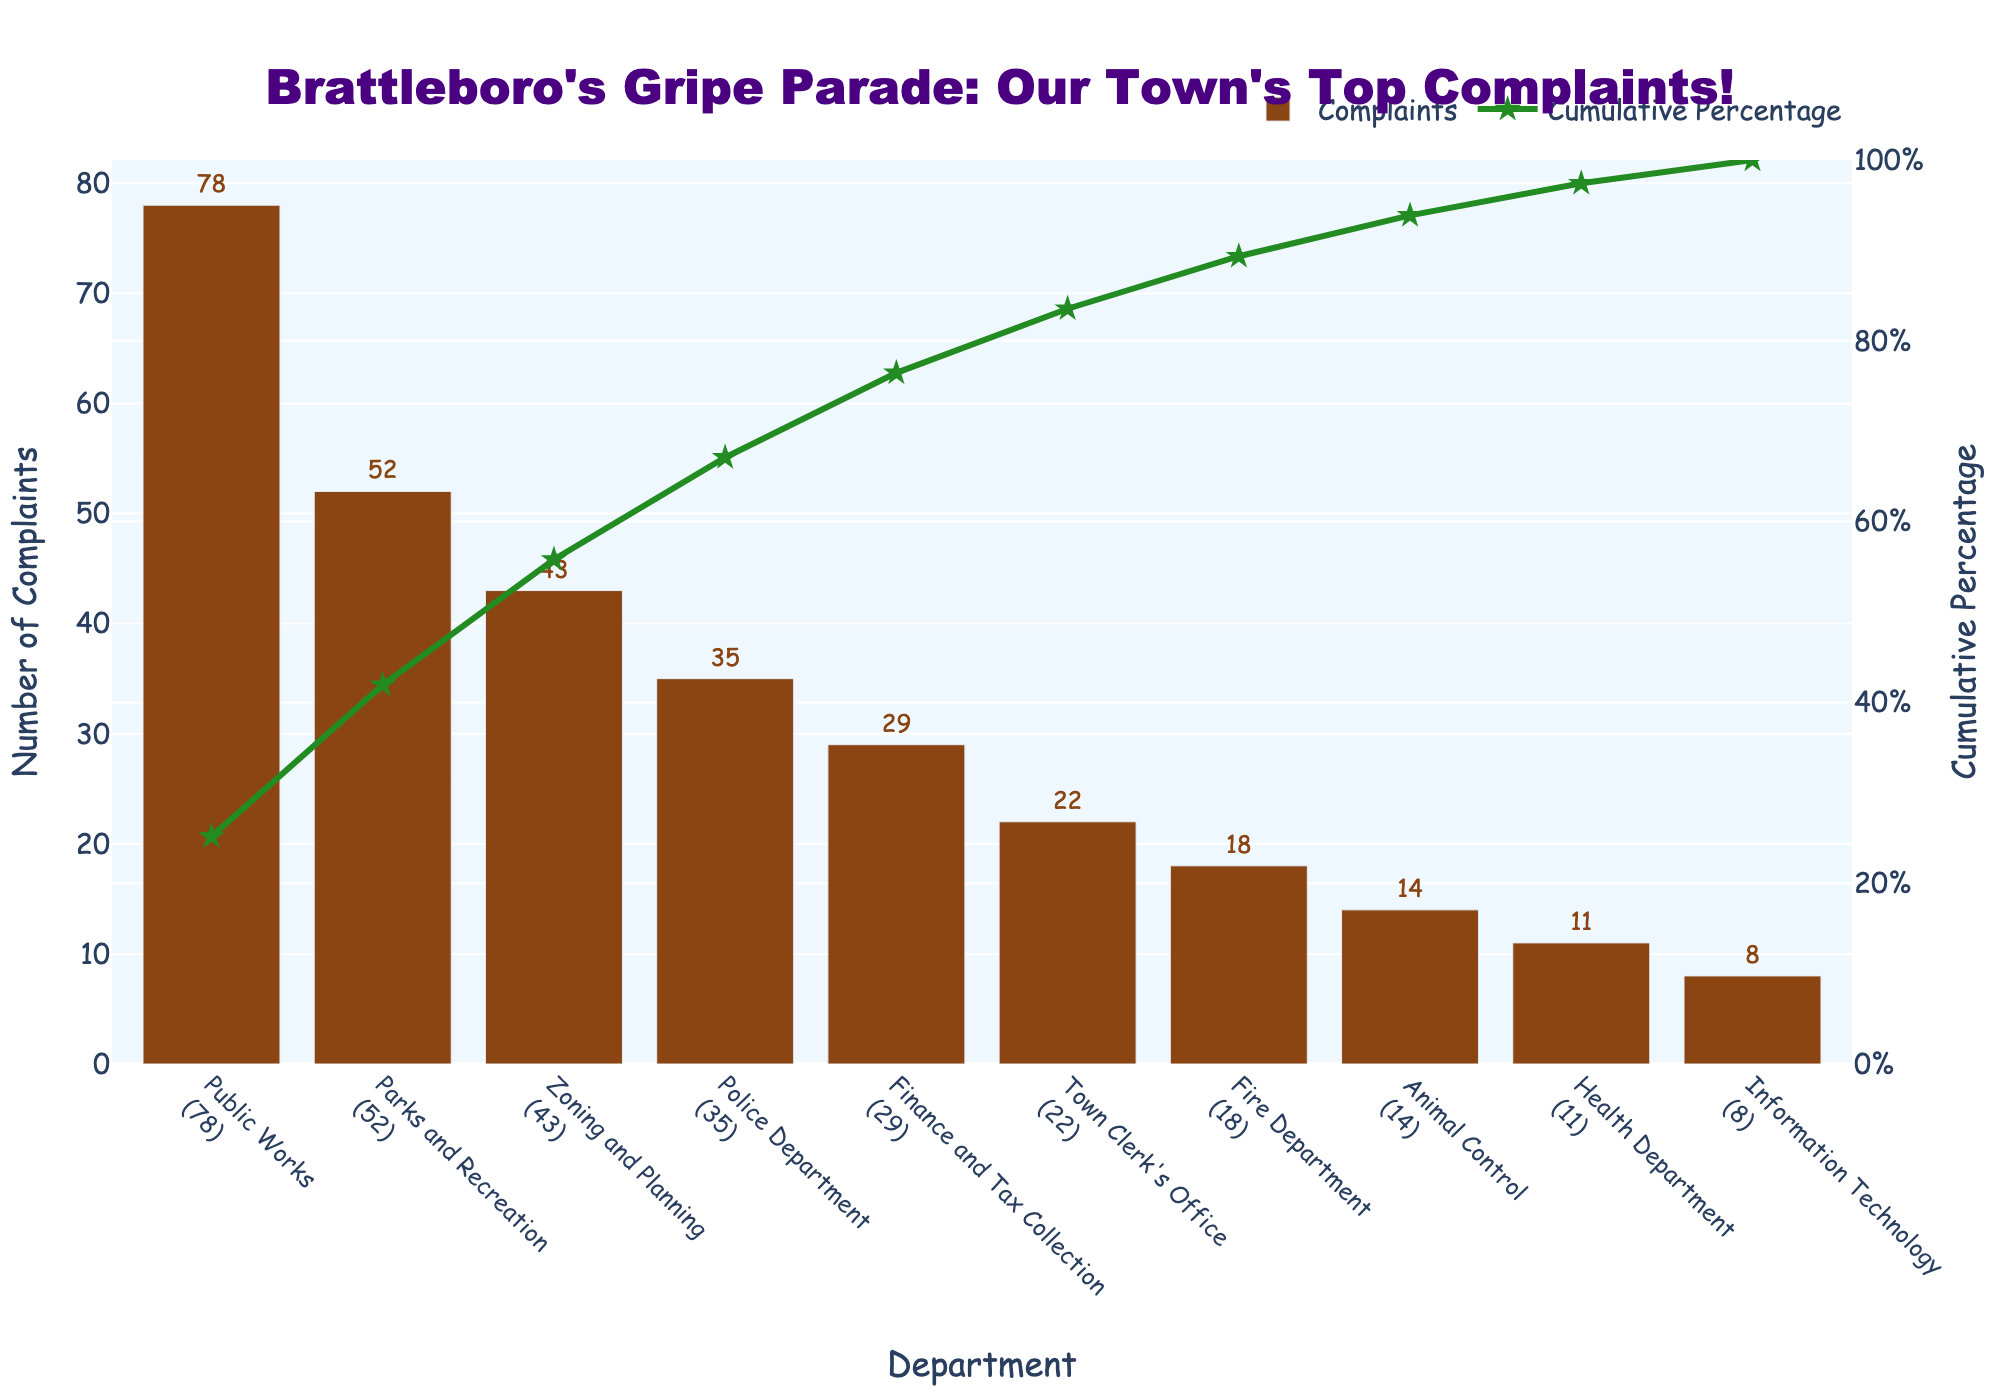What is the title of the figure? The title of the figure is located at the top and gives an overview of the chart's content.
Answer: Brattleboro's Gripe Parade: Our Town's Top Complaints! Which department received the highest number of complaints? Look at the tallest bar to identify the department with the highest complaints.
Answer: Public Works What is the cumulative percentage of complaints by the time you reach the Police Department? Combine the cumulative percentages up to and including the Police Department. The cumulative percentage for the Police Department is shown by the green line on the chart.
Answer: 76% How many more complaints did Public Works receive compared to the Fire Department? Subtract the number of complaints received by the Fire Department from those received by Public Works.
Answer: 60 Which department has the highest combined complaints: Parks and Recreation, and Zoning and Planning? Add the number of complaints for both Parks and Recreation and Zoning and Planning.
Answer: 95 What is the cumulative percentage after including complaints from the Health Department? Look at the cumulative percentage line just after the Health Department's bar.
Answer: 96.3% How does the number of complaints for the Town Clerk's Office compare to the Finance and Tax Collection? Compare the height of the bars or the numbers above the bars for both departments.
Answer: Town Clerk's Office has 7 fewer complaints Which department, Police Department or Parks and Recreation, contributes more to the cumulative percentage, and by how much? Subtract the cumulative percentage contributed by the Police Department from the cumulative percentage by the Parks and Recreation. Parks and Recreation’s cumulative percent minus the Police Department’s cumulative percent.
Answer: Parks and Recreation contributes 21.3% more What are the colors used to represent the complaints and cumulative percentage? Identify the colors of the bars for complaints and the line for the cumulative percentage. The complaints bars are a brown color, while the cumulative percentage line is a green color.
Answer: Brown for complaints, green for the cumulative percentage 